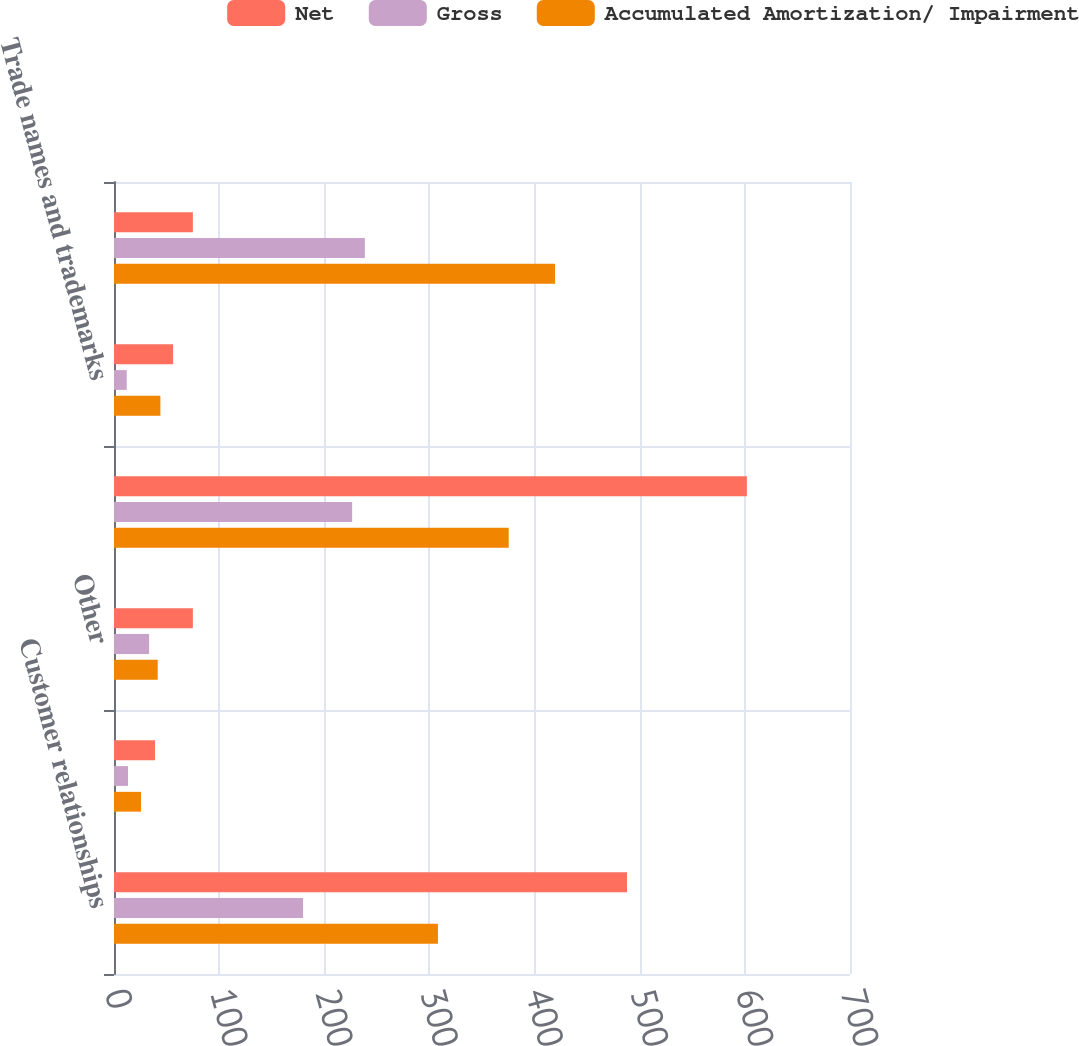<chart> <loc_0><loc_0><loc_500><loc_500><stacked_bar_chart><ecel><fcel>Customer relationships<fcel>Patents and technology<fcel>Other<fcel>Total finite-lived intangibles<fcel>Trade names and trademarks<fcel>Total Intangible Assets<nl><fcel>Net<fcel>487.9<fcel>39<fcel>75<fcel>601.9<fcel>56.2<fcel>75<nl><fcel>Gross<fcel>179.8<fcel>13.3<fcel>33.4<fcel>226.5<fcel>12.1<fcel>238.6<nl><fcel>Accumulated Amortization/ Impairment<fcel>308.1<fcel>25.7<fcel>41.6<fcel>375.4<fcel>44.1<fcel>419.5<nl></chart> 